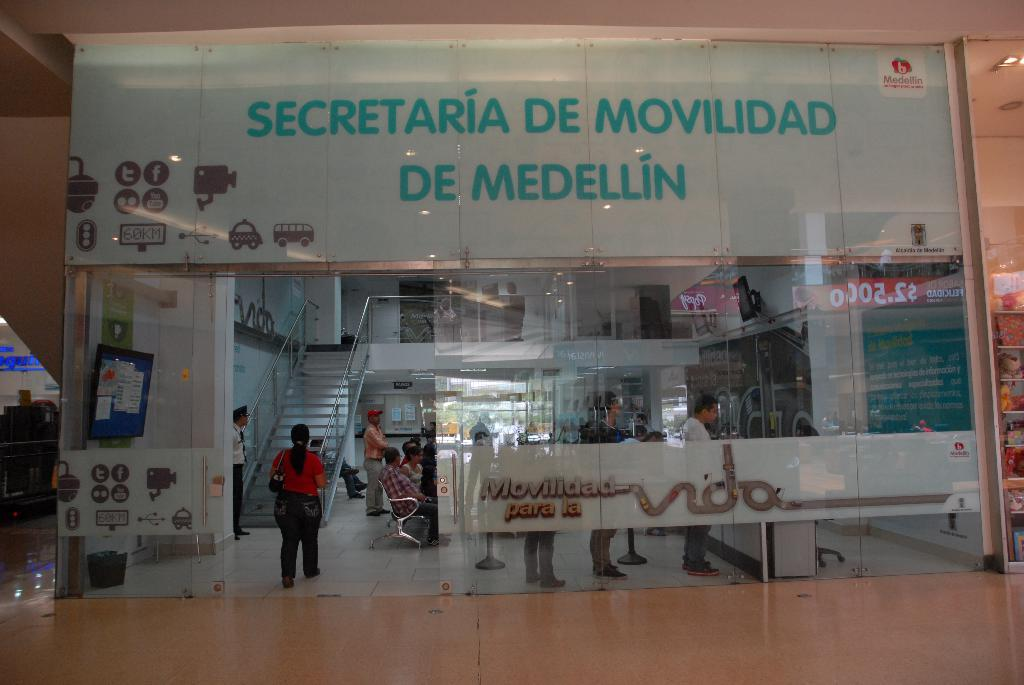What type of building is shown in the image? There is a shopping mall in the image. What feature of the shopping mall is mentioned in the facts? The shopping mall has glass walls. What activity is taking place inside the shopping mall? There are many people walking inside the shopping mall. Can you see any bottles being passed between people in the image? There is no mention of bottles in the image, so it cannot be determined if any are being passed between people. 